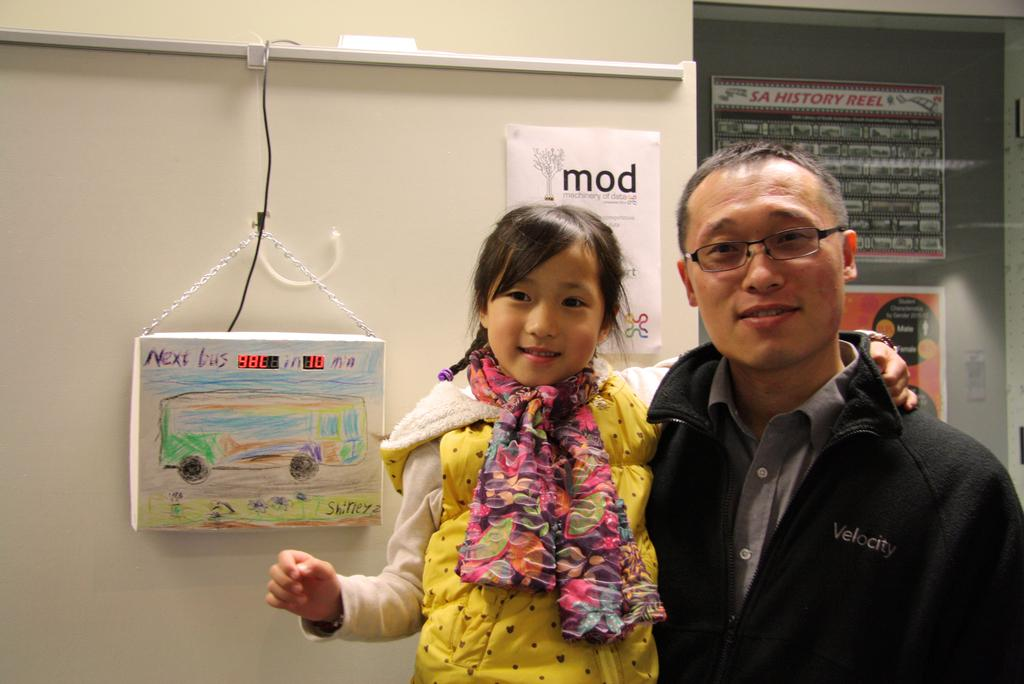What is the man in the image doing? The man is standing in the image and holding a baby. What is the man wearing in the image? The man is wearing a black coat. What is the baby wearing in the image? The baby is wearing a yellow coat. What can be seen in the background of the image? There is a wall in the background of the image. What type of potato is being used as a light source in the image? There is no potato or light source present in the image. What kind of bomb is visible in the image? There is no bomb present in the image. 